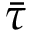<formula> <loc_0><loc_0><loc_500><loc_500>\bar { \tau }</formula> 